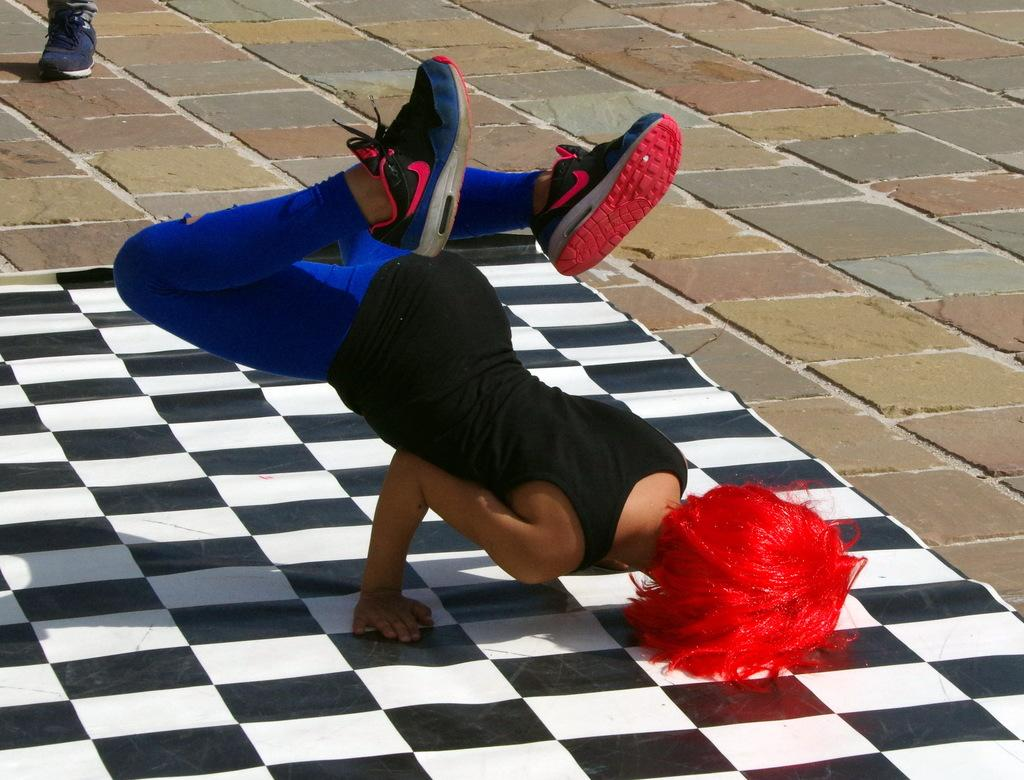What is the person in the image doing? There is a person on a mat in the image. What can be seen beneath the person? The ground is visible in the image. Can you describe any body parts of the person in the image? There is a leg of a person in the top left corner of the image. What type of reaction can be seen from the ray in the image? There is no ray present in the image, so it is not possible to determine any reaction. 